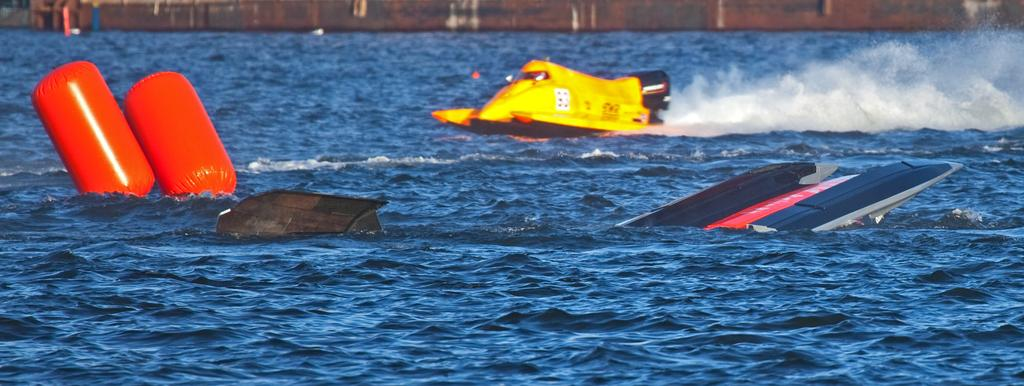What is the main subject of the image? The main subject of the image is a boat. What can be seen on the water near the boat? There are two red objects on the water. What is visible in the background of the image? There is a wall visible in the background of the image. What type of government is depicted in the image? There is no depiction of a government in the image; it features a boat, two red objects on the water, and a wall in the background. How many brothers are present in the image? There is no mention of brothers in the image; it only features a boat, two red objects on the water, and a wall in the background. 